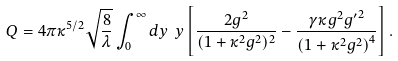<formula> <loc_0><loc_0><loc_500><loc_500>Q = 4 \pi \kappa ^ { 5 / 2 } \sqrt { \frac { 8 } { \lambda } } \int _ { 0 } ^ { \infty } d y \ y \left [ \frac { 2 g ^ { 2 } } { ( 1 + \kappa ^ { 2 } g ^ { 2 } ) ^ { 2 } } - \frac { \gamma \kappa g ^ { 2 } { g ^ { \prime } } ^ { 2 } } { \left ( 1 + \kappa ^ { 2 } g ^ { 2 } \right ) ^ { 4 } } \right ] .</formula> 